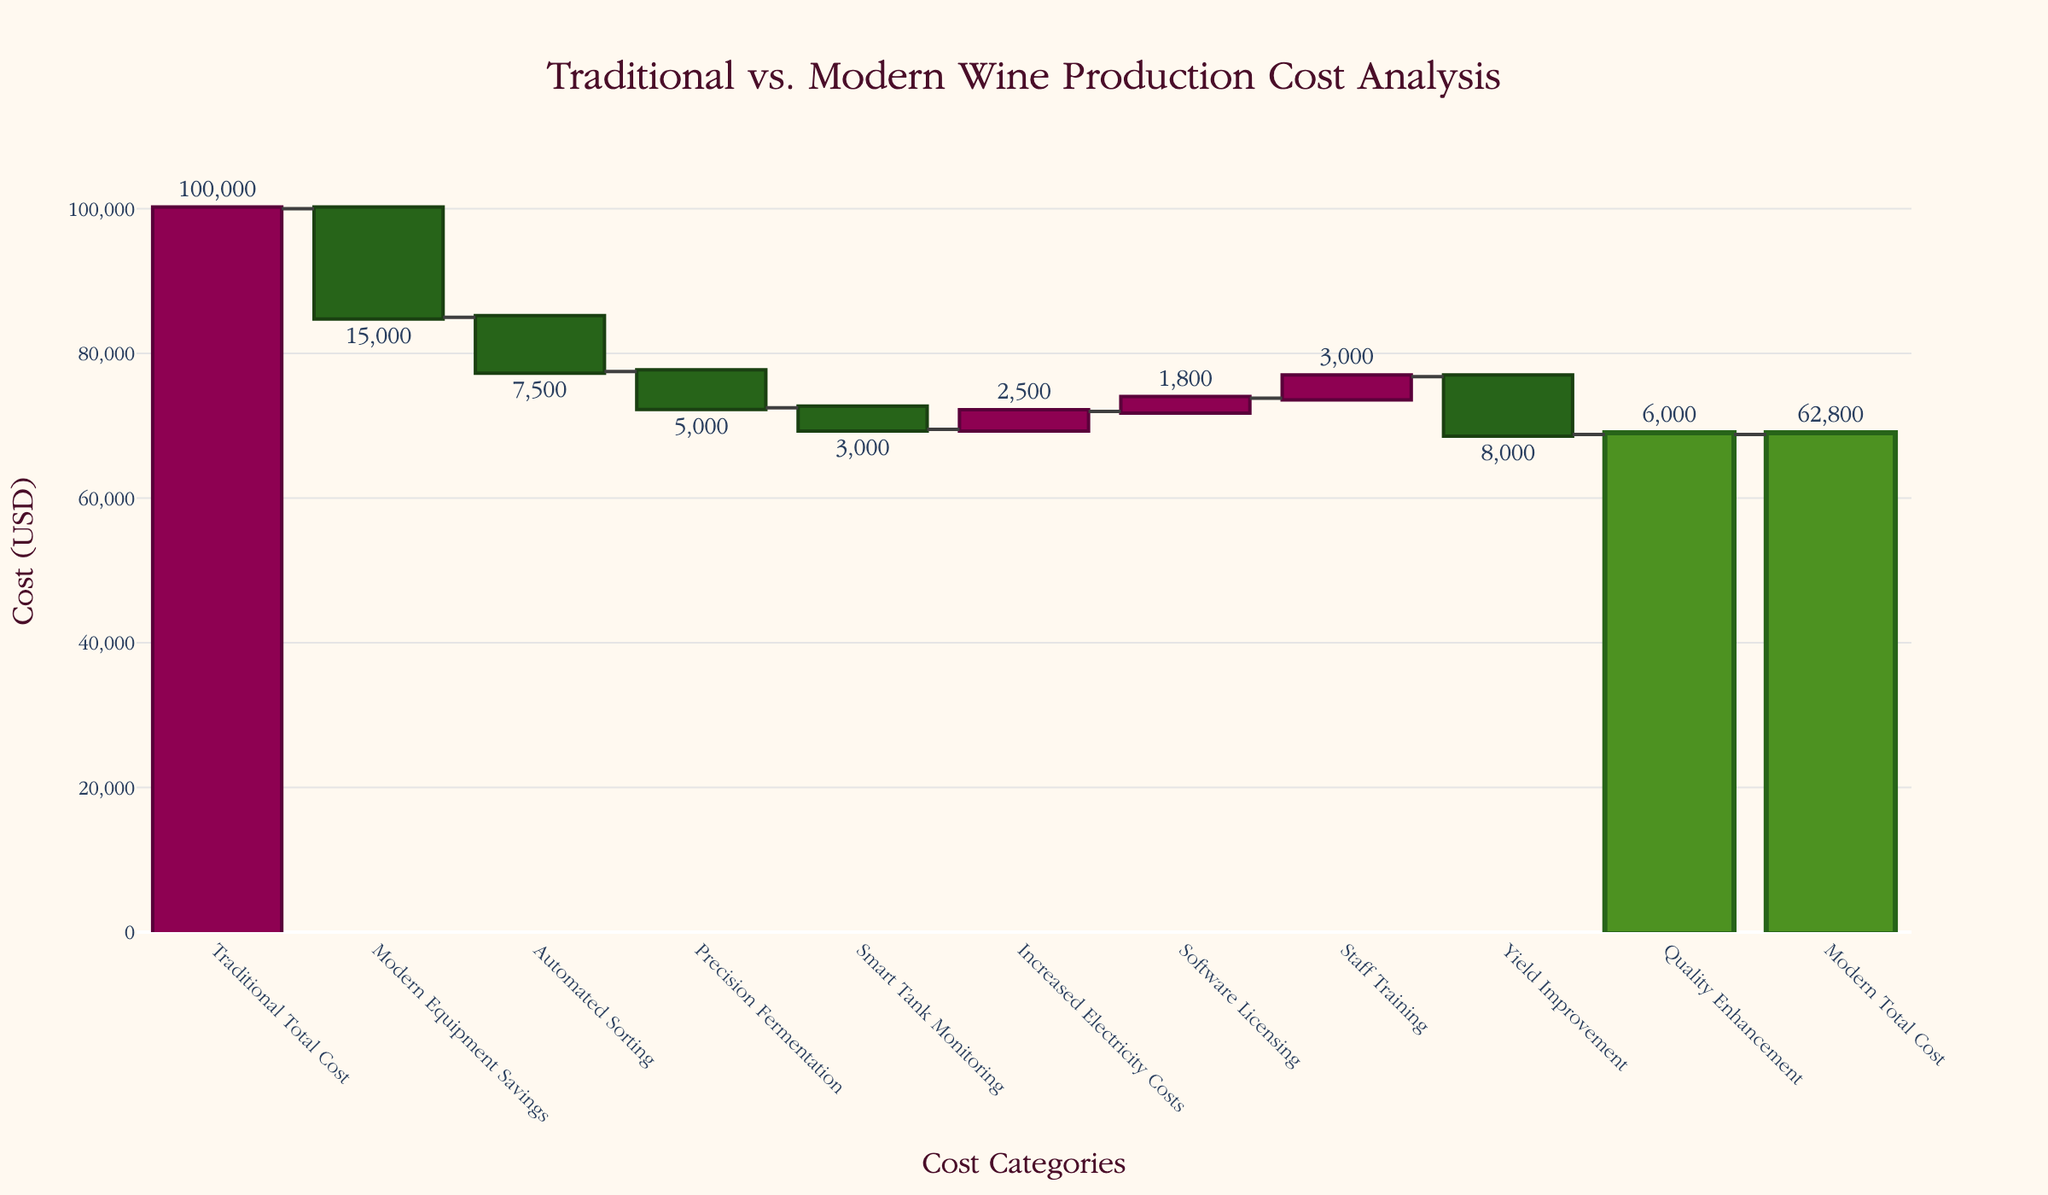What's the total cost for wine production using traditional methods? The title and first category of the Waterfall Chart specify the 'Traditional Total Cost' as a starting point for comparison. Simply looking at this category shows us the initial cost.
Answer: 100,000 How much do modern equipment savings contribute to reducing the total cost? The second category, 'Modern Equipment Savings,' shows a negative value, indicating a reduction in cost. This value is directly available.
Answer: 15,000 What are the combined cost savings from automated sorting and precision fermentation? The values for 'Automated Sorting' and 'Precision Fermentation' are both negative, indicating cost savings. Summing these values (-7,500 and -5,000) provides the combined savings.
Answer: 12,500 After accounting for the increased electricity costs and software licensing, what is the total additional cost? Both 'Increased Electricity Costs' and 'Software Licensing' contribute additional costs. Summing these positive values (2,500 and 1,800) gives the total additional cost.
Answer: 4,300 How does the total cost for modern methods compare to traditional methods? The final categories in the chart are 'Traditional Total Cost' and 'Modern Total Cost.' Comparing these two values (100,000 for traditional and 62,800 for modern) involves subtracting the modern total cost from the traditional total cost.
Answer: 37,200 What is the net effect of yield improvement and quality enhancement on the total cost? Both 'Yield Improvement' and 'Quality Enhancement' are shown as negative values, indicating cost reductions. Summing these values (-8,000 and -6,000) gives the net effect on total cost.
Answer: 14,000 What is the total cost after incorporating all cost-saving techniques except for increased electricity and software licensing costs? Sum the negative values (cost reductions) from 'Modern Equipment Savings,' 'Automated Sorting,' 'Precision Fermentation,' 'Yield Improvement,' and 'Quality Enhancement' and subtract this from the 'Traditional Total Cost.' Then, add the increased costs of 'Increased Electricity Costs' and 'Software Licensing.' The final calculation must also consider these two positive values.
Answer: 62,800 Which specific new cost has the largest contribution to the overall cost reduction? To determine this, we compare the absolute values of the negative values in the categories indicating cost savings. 'Modern Equipment Savings' has the largest absolute value (-15,000) among these.
Answer: Modern Equipment Savings 